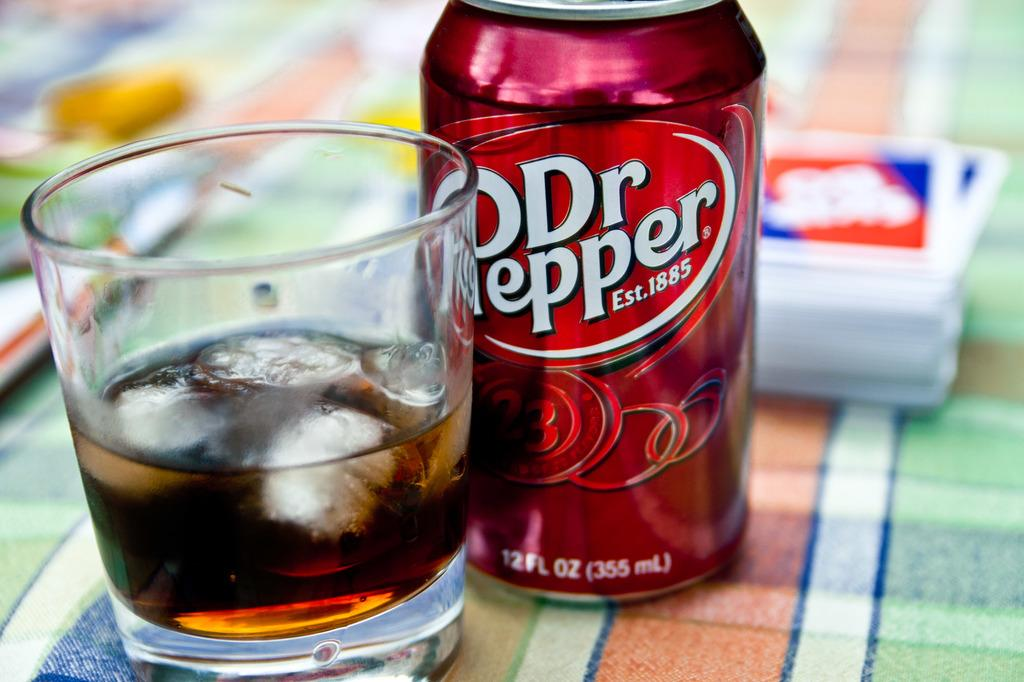Provide a one-sentence caption for the provided image. A can of Dr Pepper is on a colorful tablecloth next to a glass of the beverage with ice in it. 